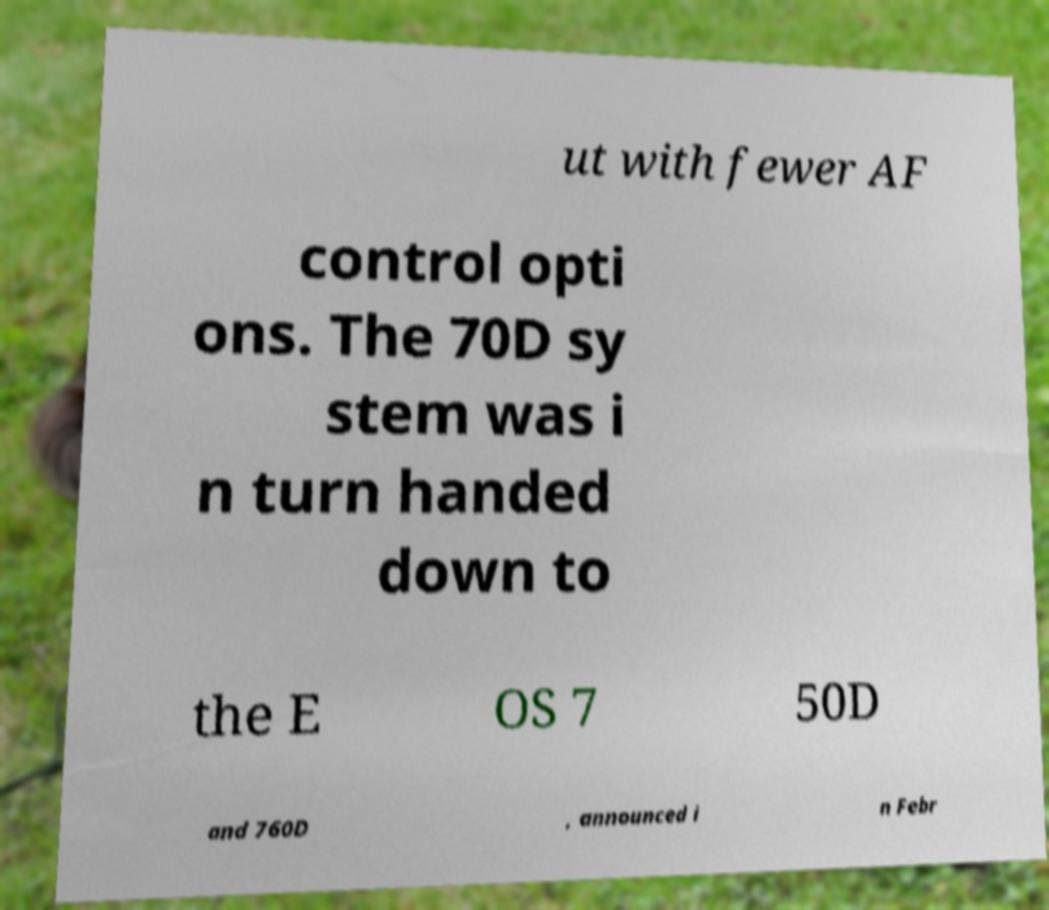Could you extract and type out the text from this image? ut with fewer AF control opti ons. The 70D sy stem was i n turn handed down to the E OS 7 50D and 760D , announced i n Febr 